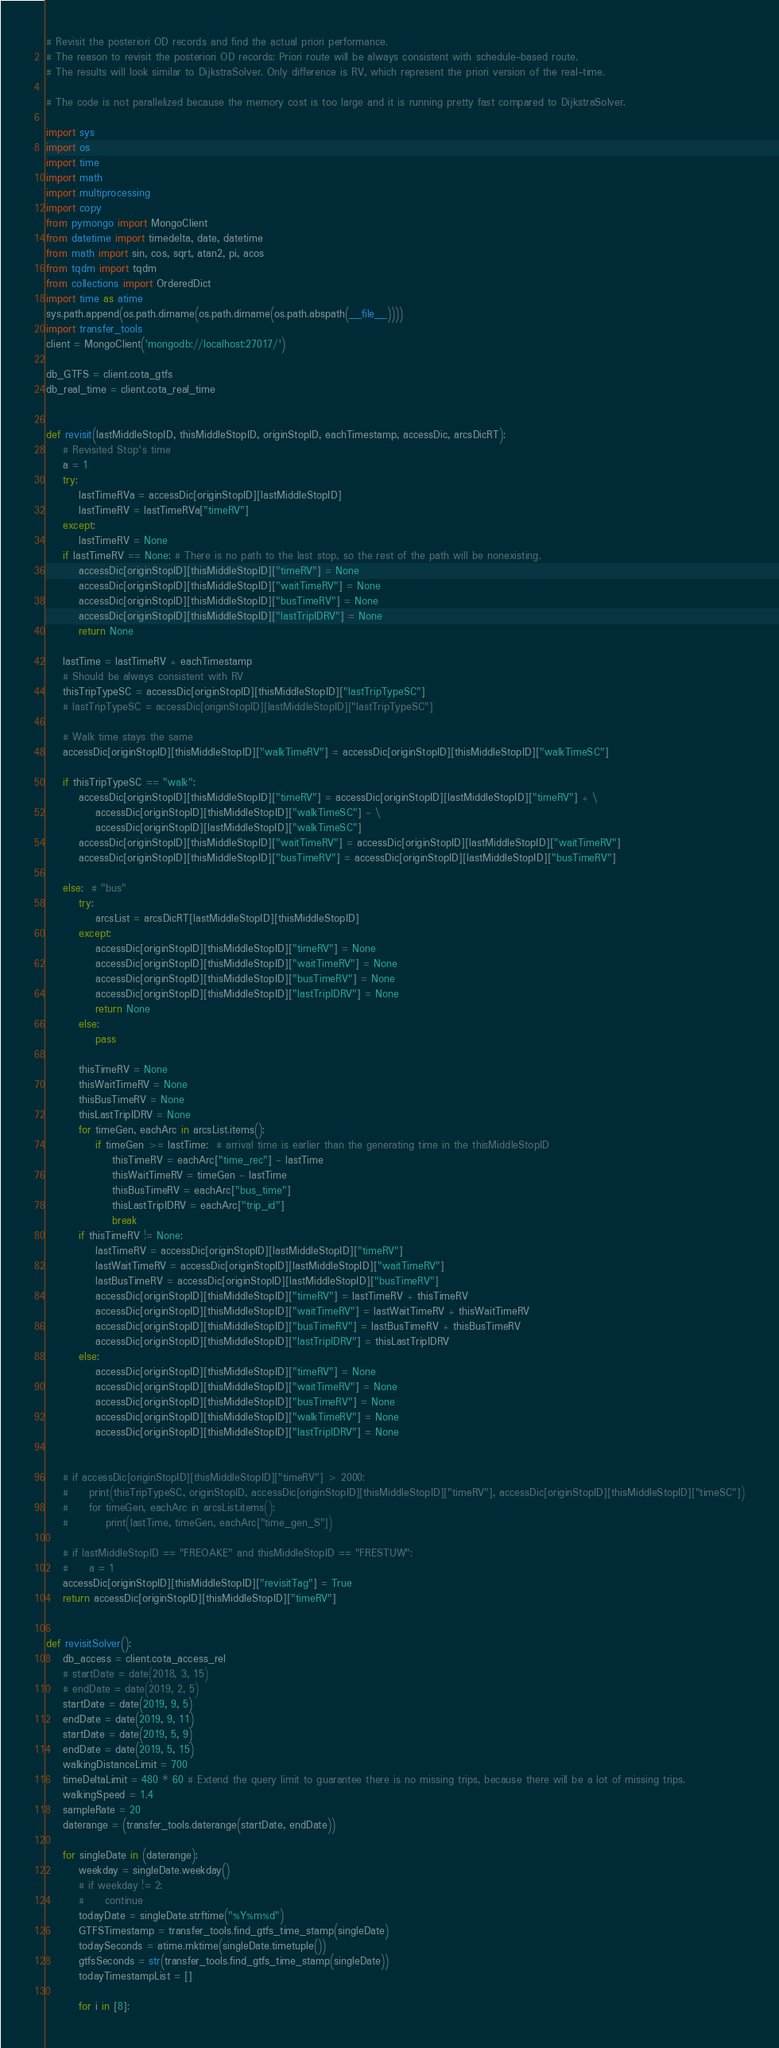<code> <loc_0><loc_0><loc_500><loc_500><_Python_># Revisit the posteriori OD records and find the actual priori performance.
# The reason to revisit the posteriori OD records: Priori route will be always consistent with schedule-based route.
# The results will look similar to DijkstraSolver. Only difference is RV, which represent the priori version of the real-time.

# The code is not parallelized because the memory cost is too large and it is running pretty fast compared to DijkstraSolver.

import sys
import os
import time
import math
import multiprocessing
import copy
from pymongo import MongoClient
from datetime import timedelta, date, datetime
from math import sin, cos, sqrt, atan2, pi, acos
from tqdm import tqdm
from collections import OrderedDict
import time as atime
sys.path.append(os.path.dirname(os.path.dirname(os.path.abspath(__file__))))
import transfer_tools
client = MongoClient('mongodb://localhost:27017/')

db_GTFS = client.cota_gtfs
db_real_time = client.cota_real_time


def revisit(lastMiddleStopID, thisMiddleStopID, originStopID, eachTimestamp, accessDic, arcsDicRT):
    # Revisited Stop's time
    a = 1
    try:
        lastTimeRVa = accessDic[originStopID][lastMiddleStopID]
        lastTimeRV = lastTimeRVa["timeRV"]
    except:
        lastTimeRV = None
    if lastTimeRV == None: # There is no path to the last stop, so the rest of the path will be nonexisting.
        accessDic[originStopID][thisMiddleStopID]["timeRV"] = None
        accessDic[originStopID][thisMiddleStopID]["waitTimeRV"] = None
        accessDic[originStopID][thisMiddleStopID]["busTimeRV"] = None
        accessDic[originStopID][thisMiddleStopID]["lastTripIDRV"] = None
        return None

    lastTime = lastTimeRV + eachTimestamp
    # Should be always consistent with RV
    thisTripTypeSC = accessDic[originStopID][thisMiddleStopID]["lastTripTypeSC"]
    # lastTripTypeSC = accessDic[originStopID][lastMiddleStopID]["lastTripTypeSC"]

    # Walk time stays the same
    accessDic[originStopID][thisMiddleStopID]["walkTimeRV"] = accessDic[originStopID][thisMiddleStopID]["walkTimeSC"]

    if thisTripTypeSC == "walk":
        accessDic[originStopID][thisMiddleStopID]["timeRV"] = accessDic[originStopID][lastMiddleStopID]["timeRV"] + \
            accessDic[originStopID][thisMiddleStopID]["walkTimeSC"] - \
            accessDic[originStopID][lastMiddleStopID]["walkTimeSC"]
        accessDic[originStopID][thisMiddleStopID]["waitTimeRV"] = accessDic[originStopID][lastMiddleStopID]["waitTimeRV"]
        accessDic[originStopID][thisMiddleStopID]["busTimeRV"] = accessDic[originStopID][lastMiddleStopID]["busTimeRV"]

    else:  # "bus"
        try:
            arcsList = arcsDicRT[lastMiddleStopID][thisMiddleStopID]
        except:
            accessDic[originStopID][thisMiddleStopID]["timeRV"] = None
            accessDic[originStopID][thisMiddleStopID]["waitTimeRV"] = None
            accessDic[originStopID][thisMiddleStopID]["busTimeRV"] = None
            accessDic[originStopID][thisMiddleStopID]["lastTripIDRV"] = None
            return None
        else:
            pass

        thisTimeRV = None
        thisWaitTimeRV = None
        thisBusTimeRV = None
        thisLastTripIDRV = None
        for timeGen, eachArc in arcsList.items():
            if timeGen >= lastTime:  # arrival time is earlier than the generating time in the thisMiddleStopID
                thisTimeRV = eachArc["time_rec"] - lastTime
                thisWaitTimeRV = timeGen - lastTime
                thisBusTimeRV = eachArc["bus_time"]
                thisLastTripIDRV = eachArc["trip_id"]
                break
        if thisTimeRV != None:
            lastTimeRV = accessDic[originStopID][lastMiddleStopID]["timeRV"]
            lastWaitTimeRV = accessDic[originStopID][lastMiddleStopID]["waitTimeRV"] 
            lastBusTimeRV = accessDic[originStopID][lastMiddleStopID]["busTimeRV"]
            accessDic[originStopID][thisMiddleStopID]["timeRV"] = lastTimeRV + thisTimeRV
            accessDic[originStopID][thisMiddleStopID]["waitTimeRV"] = lastWaitTimeRV + thisWaitTimeRV
            accessDic[originStopID][thisMiddleStopID]["busTimeRV"] = lastBusTimeRV + thisBusTimeRV
            accessDic[originStopID][thisMiddleStopID]["lastTripIDRV"] = thisLastTripIDRV
        else:
            accessDic[originStopID][thisMiddleStopID]["timeRV"] = None
            accessDic[originStopID][thisMiddleStopID]["waitTimeRV"] = None
            accessDic[originStopID][thisMiddleStopID]["busTimeRV"] = None
            accessDic[originStopID][thisMiddleStopID]["walkTimeRV"] = None
            accessDic[originStopID][thisMiddleStopID]["lastTripIDRV"] = None


    # if accessDic[originStopID][thisMiddleStopID]["timeRV"] > 2000:
    #     print(thisTripTypeSC, originStopID, accessDic[originStopID][thisMiddleStopID]["timeRV"], accessDic[originStopID][thisMiddleStopID]["timeSC"])
    #     for timeGen, eachArc in arcsList.items():
    #         print(lastTime, timeGen, eachArc["time_gen_S"])
    
    # if lastMiddleStopID == "FREOAKE" and thisMiddleStopID == "FRESTUW":
    #     a = 1
    accessDic[originStopID][thisMiddleStopID]["revisitTag"] = True
    return accessDic[originStopID][thisMiddleStopID]["timeRV"]


def revisitSolver():
    db_access = client.cota_access_rel
    # startDate = date(2018, 3, 15)
    # endDate = date(2019, 2, 5)
    startDate = date(2019, 9, 5)
    endDate = date(2019, 9, 11)
    startDate = date(2019, 5, 9)
    endDate = date(2019, 5, 15)
    walkingDistanceLimit = 700
    timeDeltaLimit = 480 * 60 # Extend the query limit to guarantee there is no missing trips, because there will be a lot of missing trips.
    walkingSpeed = 1.4
    sampleRate = 20
    daterange = (transfer_tools.daterange(startDate, endDate))

    for singleDate in (daterange):
        weekday = singleDate.weekday()
        # if weekday != 2:
        #     continue
        todayDate = singleDate.strftime("%Y%m%d")
        GTFSTimestamp = transfer_tools.find_gtfs_time_stamp(singleDate)
        todaySeconds = atime.mktime(singleDate.timetuple())
        gtfsSeconds = str(transfer_tools.find_gtfs_time_stamp(singleDate))
        todayTimestampList = []

        for i in [8]:</code> 